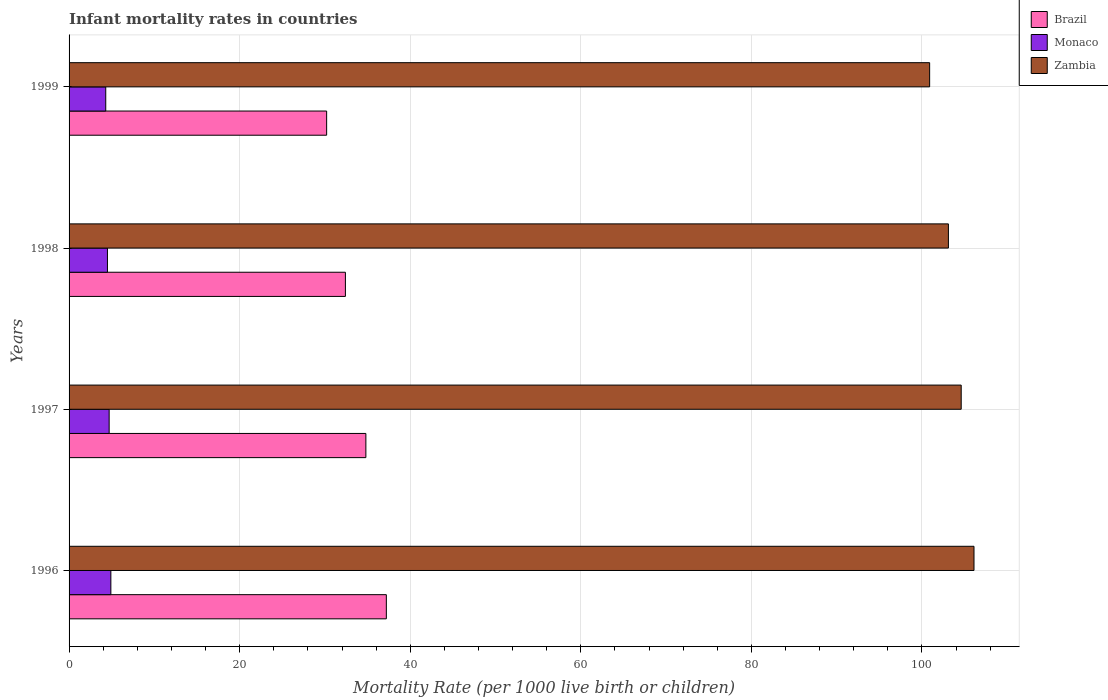How many groups of bars are there?
Your answer should be very brief. 4. Are the number of bars on each tick of the Y-axis equal?
Provide a succinct answer. Yes. How many bars are there on the 2nd tick from the bottom?
Provide a succinct answer. 3. What is the label of the 2nd group of bars from the top?
Keep it short and to the point. 1998. What is the infant mortality rate in Zambia in 1997?
Make the answer very short. 104.6. Across all years, what is the maximum infant mortality rate in Zambia?
Provide a succinct answer. 106.1. Across all years, what is the minimum infant mortality rate in Zambia?
Offer a terse response. 100.9. In which year was the infant mortality rate in Zambia maximum?
Offer a very short reply. 1996. In which year was the infant mortality rate in Monaco minimum?
Give a very brief answer. 1999. What is the total infant mortality rate in Monaco in the graph?
Offer a terse response. 18.4. What is the difference between the infant mortality rate in Monaco in 1997 and that in 1998?
Ensure brevity in your answer.  0.2. What is the difference between the infant mortality rate in Zambia in 1997 and the infant mortality rate in Brazil in 1999?
Provide a succinct answer. 74.4. What is the average infant mortality rate in Zambia per year?
Your answer should be compact. 103.67. In the year 1999, what is the difference between the infant mortality rate in Brazil and infant mortality rate in Zambia?
Keep it short and to the point. -70.7. In how many years, is the infant mortality rate in Brazil greater than 48 ?
Provide a short and direct response. 0. What is the ratio of the infant mortality rate in Brazil in 1998 to that in 1999?
Keep it short and to the point. 1.07. Is the difference between the infant mortality rate in Brazil in 1996 and 1999 greater than the difference between the infant mortality rate in Zambia in 1996 and 1999?
Make the answer very short. Yes. What is the difference between the highest and the second highest infant mortality rate in Zambia?
Provide a short and direct response. 1.5. What is the difference between the highest and the lowest infant mortality rate in Monaco?
Keep it short and to the point. 0.6. In how many years, is the infant mortality rate in Zambia greater than the average infant mortality rate in Zambia taken over all years?
Your answer should be compact. 2. What does the 3rd bar from the top in 1997 represents?
Make the answer very short. Brazil. What does the 3rd bar from the bottom in 1999 represents?
Provide a succinct answer. Zambia. Is it the case that in every year, the sum of the infant mortality rate in Monaco and infant mortality rate in Zambia is greater than the infant mortality rate in Brazil?
Offer a terse response. Yes. How many years are there in the graph?
Provide a short and direct response. 4. What is the difference between two consecutive major ticks on the X-axis?
Make the answer very short. 20. Does the graph contain any zero values?
Offer a very short reply. No. Where does the legend appear in the graph?
Offer a very short reply. Top right. What is the title of the graph?
Provide a succinct answer. Infant mortality rates in countries. What is the label or title of the X-axis?
Your answer should be very brief. Mortality Rate (per 1000 live birth or children). What is the label or title of the Y-axis?
Provide a succinct answer. Years. What is the Mortality Rate (per 1000 live birth or children) of Brazil in 1996?
Ensure brevity in your answer.  37.2. What is the Mortality Rate (per 1000 live birth or children) in Monaco in 1996?
Provide a short and direct response. 4.9. What is the Mortality Rate (per 1000 live birth or children) in Zambia in 1996?
Ensure brevity in your answer.  106.1. What is the Mortality Rate (per 1000 live birth or children) in Brazil in 1997?
Ensure brevity in your answer.  34.8. What is the Mortality Rate (per 1000 live birth or children) in Zambia in 1997?
Offer a terse response. 104.6. What is the Mortality Rate (per 1000 live birth or children) in Brazil in 1998?
Your response must be concise. 32.4. What is the Mortality Rate (per 1000 live birth or children) in Zambia in 1998?
Provide a succinct answer. 103.1. What is the Mortality Rate (per 1000 live birth or children) in Brazil in 1999?
Offer a very short reply. 30.2. What is the Mortality Rate (per 1000 live birth or children) of Zambia in 1999?
Your answer should be very brief. 100.9. Across all years, what is the maximum Mortality Rate (per 1000 live birth or children) in Brazil?
Keep it short and to the point. 37.2. Across all years, what is the maximum Mortality Rate (per 1000 live birth or children) of Zambia?
Your response must be concise. 106.1. Across all years, what is the minimum Mortality Rate (per 1000 live birth or children) of Brazil?
Your answer should be very brief. 30.2. Across all years, what is the minimum Mortality Rate (per 1000 live birth or children) in Monaco?
Your response must be concise. 4.3. Across all years, what is the minimum Mortality Rate (per 1000 live birth or children) in Zambia?
Provide a succinct answer. 100.9. What is the total Mortality Rate (per 1000 live birth or children) of Brazil in the graph?
Your answer should be compact. 134.6. What is the total Mortality Rate (per 1000 live birth or children) of Monaco in the graph?
Your answer should be very brief. 18.4. What is the total Mortality Rate (per 1000 live birth or children) in Zambia in the graph?
Ensure brevity in your answer.  414.7. What is the difference between the Mortality Rate (per 1000 live birth or children) in Zambia in 1996 and that in 1997?
Your response must be concise. 1.5. What is the difference between the Mortality Rate (per 1000 live birth or children) of Monaco in 1996 and that in 1998?
Keep it short and to the point. 0.4. What is the difference between the Mortality Rate (per 1000 live birth or children) in Monaco in 1996 and that in 1999?
Offer a very short reply. 0.6. What is the difference between the Mortality Rate (per 1000 live birth or children) of Zambia in 1996 and that in 1999?
Provide a short and direct response. 5.2. What is the difference between the Mortality Rate (per 1000 live birth or children) of Monaco in 1997 and that in 1998?
Provide a succinct answer. 0.2. What is the difference between the Mortality Rate (per 1000 live birth or children) of Zambia in 1997 and that in 1999?
Your answer should be very brief. 3.7. What is the difference between the Mortality Rate (per 1000 live birth or children) of Brazil in 1998 and that in 1999?
Offer a terse response. 2.2. What is the difference between the Mortality Rate (per 1000 live birth or children) of Monaco in 1998 and that in 1999?
Give a very brief answer. 0.2. What is the difference between the Mortality Rate (per 1000 live birth or children) in Zambia in 1998 and that in 1999?
Your response must be concise. 2.2. What is the difference between the Mortality Rate (per 1000 live birth or children) in Brazil in 1996 and the Mortality Rate (per 1000 live birth or children) in Monaco in 1997?
Keep it short and to the point. 32.5. What is the difference between the Mortality Rate (per 1000 live birth or children) of Brazil in 1996 and the Mortality Rate (per 1000 live birth or children) of Zambia in 1997?
Provide a succinct answer. -67.4. What is the difference between the Mortality Rate (per 1000 live birth or children) in Monaco in 1996 and the Mortality Rate (per 1000 live birth or children) in Zambia in 1997?
Provide a succinct answer. -99.7. What is the difference between the Mortality Rate (per 1000 live birth or children) in Brazil in 1996 and the Mortality Rate (per 1000 live birth or children) in Monaco in 1998?
Ensure brevity in your answer.  32.7. What is the difference between the Mortality Rate (per 1000 live birth or children) of Brazil in 1996 and the Mortality Rate (per 1000 live birth or children) of Zambia in 1998?
Your response must be concise. -65.9. What is the difference between the Mortality Rate (per 1000 live birth or children) in Monaco in 1996 and the Mortality Rate (per 1000 live birth or children) in Zambia in 1998?
Offer a very short reply. -98.2. What is the difference between the Mortality Rate (per 1000 live birth or children) in Brazil in 1996 and the Mortality Rate (per 1000 live birth or children) in Monaco in 1999?
Your response must be concise. 32.9. What is the difference between the Mortality Rate (per 1000 live birth or children) in Brazil in 1996 and the Mortality Rate (per 1000 live birth or children) in Zambia in 1999?
Offer a terse response. -63.7. What is the difference between the Mortality Rate (per 1000 live birth or children) in Monaco in 1996 and the Mortality Rate (per 1000 live birth or children) in Zambia in 1999?
Keep it short and to the point. -96. What is the difference between the Mortality Rate (per 1000 live birth or children) in Brazil in 1997 and the Mortality Rate (per 1000 live birth or children) in Monaco in 1998?
Your response must be concise. 30.3. What is the difference between the Mortality Rate (per 1000 live birth or children) of Brazil in 1997 and the Mortality Rate (per 1000 live birth or children) of Zambia in 1998?
Give a very brief answer. -68.3. What is the difference between the Mortality Rate (per 1000 live birth or children) in Monaco in 1997 and the Mortality Rate (per 1000 live birth or children) in Zambia in 1998?
Your answer should be compact. -98.4. What is the difference between the Mortality Rate (per 1000 live birth or children) of Brazil in 1997 and the Mortality Rate (per 1000 live birth or children) of Monaco in 1999?
Provide a succinct answer. 30.5. What is the difference between the Mortality Rate (per 1000 live birth or children) of Brazil in 1997 and the Mortality Rate (per 1000 live birth or children) of Zambia in 1999?
Your answer should be compact. -66.1. What is the difference between the Mortality Rate (per 1000 live birth or children) of Monaco in 1997 and the Mortality Rate (per 1000 live birth or children) of Zambia in 1999?
Provide a short and direct response. -96.2. What is the difference between the Mortality Rate (per 1000 live birth or children) of Brazil in 1998 and the Mortality Rate (per 1000 live birth or children) of Monaco in 1999?
Provide a succinct answer. 28.1. What is the difference between the Mortality Rate (per 1000 live birth or children) of Brazil in 1998 and the Mortality Rate (per 1000 live birth or children) of Zambia in 1999?
Offer a terse response. -68.5. What is the difference between the Mortality Rate (per 1000 live birth or children) of Monaco in 1998 and the Mortality Rate (per 1000 live birth or children) of Zambia in 1999?
Your response must be concise. -96.4. What is the average Mortality Rate (per 1000 live birth or children) of Brazil per year?
Make the answer very short. 33.65. What is the average Mortality Rate (per 1000 live birth or children) in Monaco per year?
Your answer should be very brief. 4.6. What is the average Mortality Rate (per 1000 live birth or children) of Zambia per year?
Offer a very short reply. 103.67. In the year 1996, what is the difference between the Mortality Rate (per 1000 live birth or children) of Brazil and Mortality Rate (per 1000 live birth or children) of Monaco?
Provide a succinct answer. 32.3. In the year 1996, what is the difference between the Mortality Rate (per 1000 live birth or children) in Brazil and Mortality Rate (per 1000 live birth or children) in Zambia?
Make the answer very short. -68.9. In the year 1996, what is the difference between the Mortality Rate (per 1000 live birth or children) in Monaco and Mortality Rate (per 1000 live birth or children) in Zambia?
Offer a terse response. -101.2. In the year 1997, what is the difference between the Mortality Rate (per 1000 live birth or children) in Brazil and Mortality Rate (per 1000 live birth or children) in Monaco?
Offer a very short reply. 30.1. In the year 1997, what is the difference between the Mortality Rate (per 1000 live birth or children) in Brazil and Mortality Rate (per 1000 live birth or children) in Zambia?
Offer a terse response. -69.8. In the year 1997, what is the difference between the Mortality Rate (per 1000 live birth or children) of Monaco and Mortality Rate (per 1000 live birth or children) of Zambia?
Provide a succinct answer. -99.9. In the year 1998, what is the difference between the Mortality Rate (per 1000 live birth or children) in Brazil and Mortality Rate (per 1000 live birth or children) in Monaco?
Your answer should be very brief. 27.9. In the year 1998, what is the difference between the Mortality Rate (per 1000 live birth or children) in Brazil and Mortality Rate (per 1000 live birth or children) in Zambia?
Provide a succinct answer. -70.7. In the year 1998, what is the difference between the Mortality Rate (per 1000 live birth or children) of Monaco and Mortality Rate (per 1000 live birth or children) of Zambia?
Offer a terse response. -98.6. In the year 1999, what is the difference between the Mortality Rate (per 1000 live birth or children) of Brazil and Mortality Rate (per 1000 live birth or children) of Monaco?
Ensure brevity in your answer.  25.9. In the year 1999, what is the difference between the Mortality Rate (per 1000 live birth or children) in Brazil and Mortality Rate (per 1000 live birth or children) in Zambia?
Ensure brevity in your answer.  -70.7. In the year 1999, what is the difference between the Mortality Rate (per 1000 live birth or children) of Monaco and Mortality Rate (per 1000 live birth or children) of Zambia?
Offer a terse response. -96.6. What is the ratio of the Mortality Rate (per 1000 live birth or children) of Brazil in 1996 to that in 1997?
Your answer should be very brief. 1.07. What is the ratio of the Mortality Rate (per 1000 live birth or children) in Monaco in 1996 to that in 1997?
Provide a succinct answer. 1.04. What is the ratio of the Mortality Rate (per 1000 live birth or children) in Zambia in 1996 to that in 1997?
Your answer should be very brief. 1.01. What is the ratio of the Mortality Rate (per 1000 live birth or children) of Brazil in 1996 to that in 1998?
Offer a very short reply. 1.15. What is the ratio of the Mortality Rate (per 1000 live birth or children) of Monaco in 1996 to that in 1998?
Make the answer very short. 1.09. What is the ratio of the Mortality Rate (per 1000 live birth or children) in Zambia in 1996 to that in 1998?
Provide a short and direct response. 1.03. What is the ratio of the Mortality Rate (per 1000 live birth or children) in Brazil in 1996 to that in 1999?
Your response must be concise. 1.23. What is the ratio of the Mortality Rate (per 1000 live birth or children) of Monaco in 1996 to that in 1999?
Offer a terse response. 1.14. What is the ratio of the Mortality Rate (per 1000 live birth or children) of Zambia in 1996 to that in 1999?
Your answer should be very brief. 1.05. What is the ratio of the Mortality Rate (per 1000 live birth or children) of Brazil in 1997 to that in 1998?
Ensure brevity in your answer.  1.07. What is the ratio of the Mortality Rate (per 1000 live birth or children) of Monaco in 1997 to that in 1998?
Your answer should be compact. 1.04. What is the ratio of the Mortality Rate (per 1000 live birth or children) of Zambia in 1997 to that in 1998?
Your answer should be very brief. 1.01. What is the ratio of the Mortality Rate (per 1000 live birth or children) in Brazil in 1997 to that in 1999?
Your answer should be compact. 1.15. What is the ratio of the Mortality Rate (per 1000 live birth or children) of Monaco in 1997 to that in 1999?
Ensure brevity in your answer.  1.09. What is the ratio of the Mortality Rate (per 1000 live birth or children) in Zambia in 1997 to that in 1999?
Offer a terse response. 1.04. What is the ratio of the Mortality Rate (per 1000 live birth or children) of Brazil in 1998 to that in 1999?
Make the answer very short. 1.07. What is the ratio of the Mortality Rate (per 1000 live birth or children) of Monaco in 1998 to that in 1999?
Give a very brief answer. 1.05. What is the ratio of the Mortality Rate (per 1000 live birth or children) in Zambia in 1998 to that in 1999?
Provide a succinct answer. 1.02. What is the difference between the highest and the second highest Mortality Rate (per 1000 live birth or children) in Brazil?
Provide a succinct answer. 2.4. What is the difference between the highest and the lowest Mortality Rate (per 1000 live birth or children) of Brazil?
Your response must be concise. 7. What is the difference between the highest and the lowest Mortality Rate (per 1000 live birth or children) in Zambia?
Offer a terse response. 5.2. 